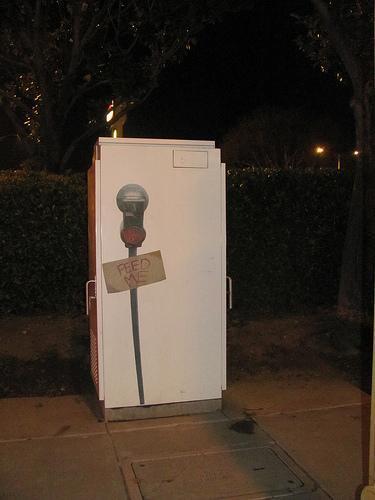How many meters are pictured?
Give a very brief answer. 1. 